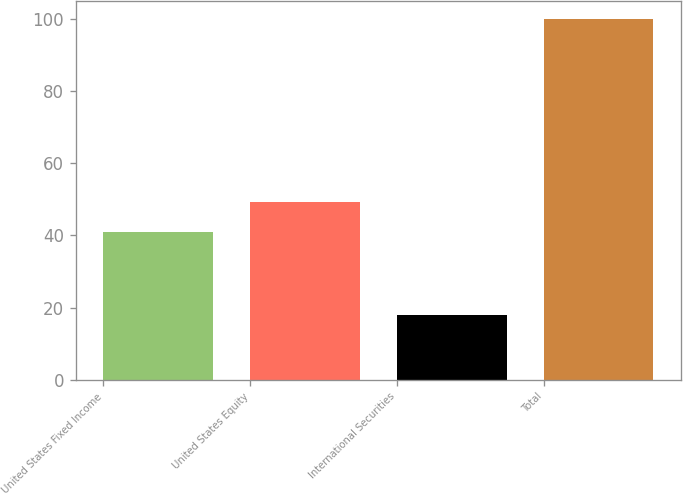Convert chart to OTSL. <chart><loc_0><loc_0><loc_500><loc_500><bar_chart><fcel>United States Fixed Income<fcel>United States Equity<fcel>International Securities<fcel>Total<nl><fcel>41<fcel>49.2<fcel>18<fcel>100<nl></chart> 